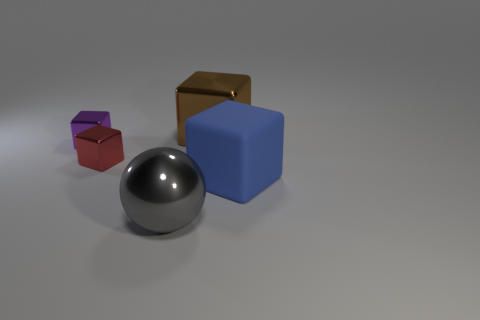Does the red metal object have the same size as the thing that is in front of the matte block?
Give a very brief answer. No. What number of spheres are either things or large cyan matte things?
Your response must be concise. 1. What is the size of the purple block that is made of the same material as the red object?
Give a very brief answer. Small. Is the size of the metallic thing that is to the right of the gray metal ball the same as the metal block that is in front of the purple shiny block?
Ensure brevity in your answer.  No. What number of objects are red blocks or large gray metal balls?
Ensure brevity in your answer.  2. What shape is the red thing?
Provide a succinct answer. Cube. What is the size of the brown metal object that is the same shape as the tiny red thing?
Keep it short and to the point. Large. Are there any other things that have the same material as the red cube?
Give a very brief answer. Yes. There is a metal thing that is behind the small metallic block that is on the left side of the red block; what size is it?
Offer a very short reply. Large. Is the number of purple shiny objects right of the large matte block the same as the number of metal balls?
Make the answer very short. No. 